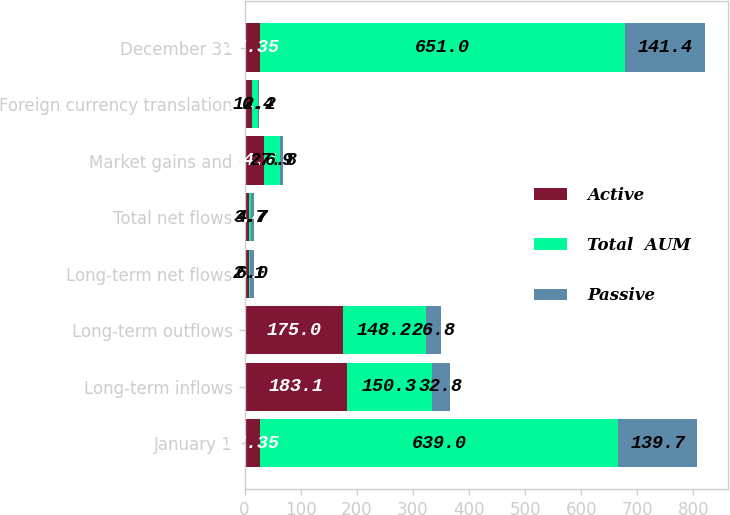<chart> <loc_0><loc_0><loc_500><loc_500><stacked_bar_chart><ecel><fcel>January 1<fcel>Long-term inflows<fcel>Long-term outflows<fcel>Long-term net flows<fcel>Total net flows<fcel>Market gains and<fcel>Foreign currency translation<fcel>December 31<nl><fcel>Active<fcel>27.35<fcel>183.1<fcel>175<fcel>8.1<fcel>8.4<fcel>34.7<fcel>12.6<fcel>27.35<nl><fcel>Total  AUM<fcel>639<fcel>150.3<fcel>148.2<fcel>2.1<fcel>3.7<fcel>27.9<fcel>12.2<fcel>651<nl><fcel>Passive<fcel>139.7<fcel>32.8<fcel>26.8<fcel>6<fcel>4.7<fcel>6.8<fcel>0.4<fcel>141.4<nl></chart> 